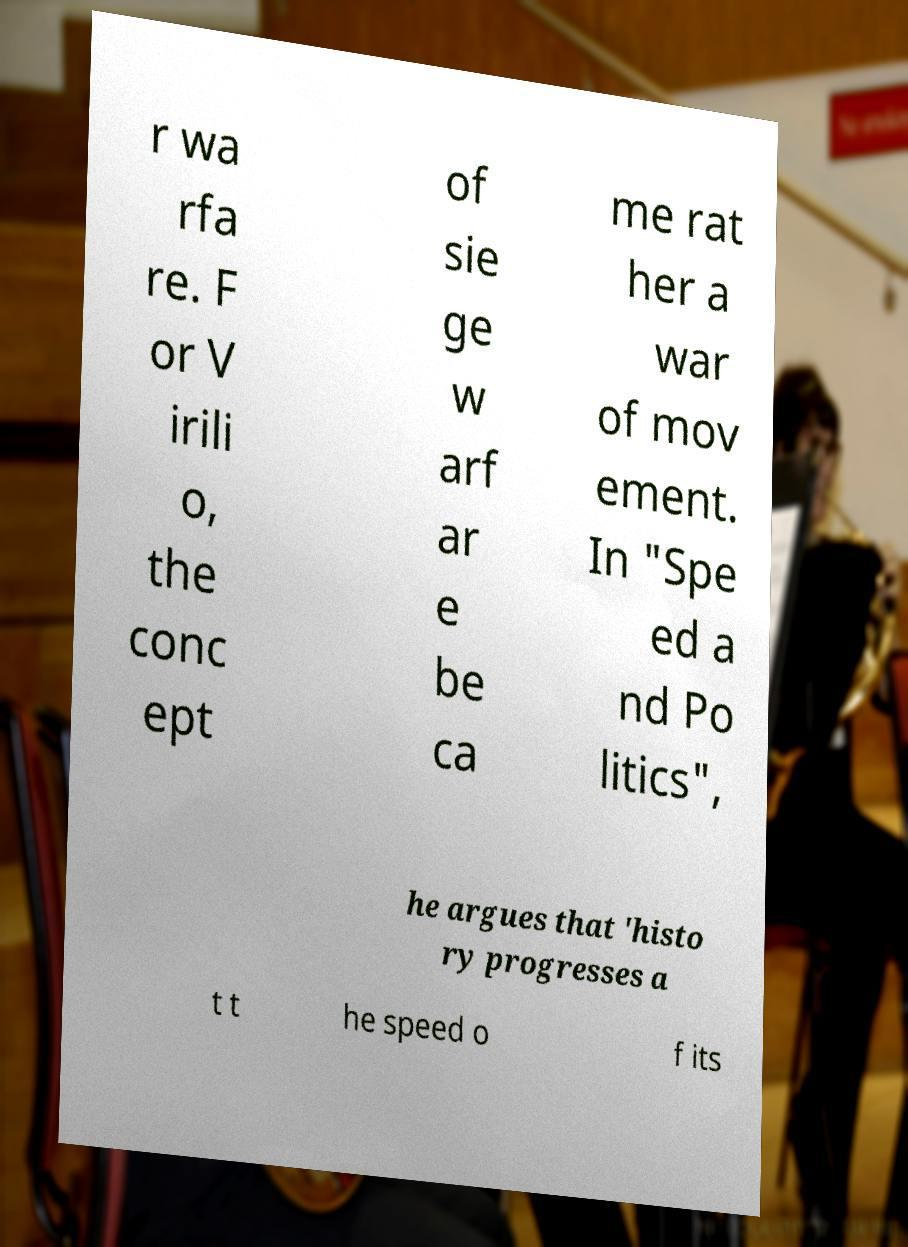Please read and relay the text visible in this image. What does it say? r wa rfa re. F or V irili o, the conc ept of sie ge w arf ar e be ca me rat her a war of mov ement. In "Spe ed a nd Po litics", he argues that 'histo ry progresses a t t he speed o f its 